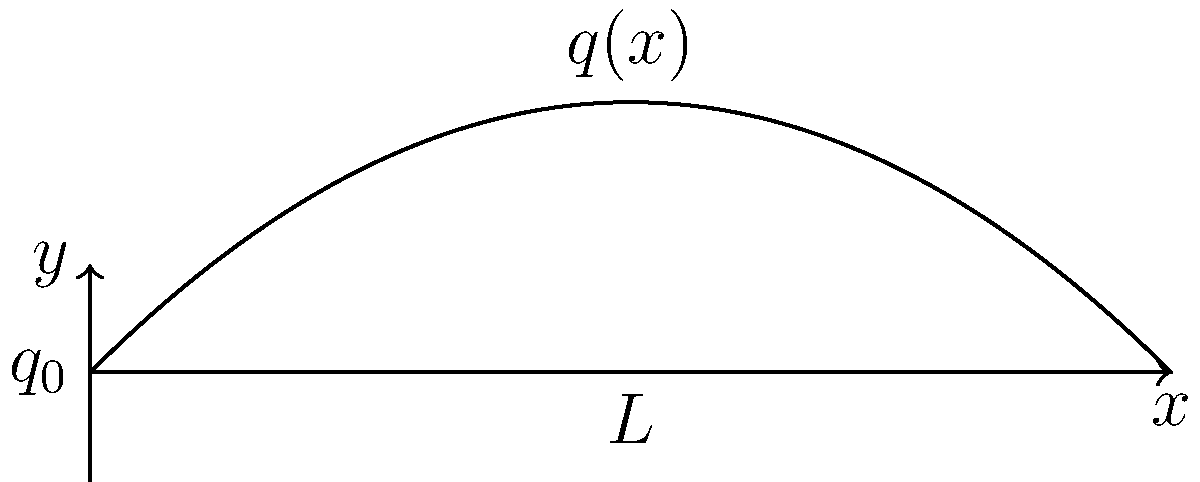In the context of Latin American revolutionary movements, consider a metaphorical "beam of resistance" represented by women's participation. This beam is subjected to a distributed load $q(x)$ that varies quadratically along its length $L$, as shown in the figure. The load represents the intensity of revolutionary activity, with $q(x) = q_0(1 - \frac{x^2}{L^2})$, where $q_0$ is the maximum intensity at $x = 0$. Determine the expression for the bending moment $M(x)$ at any point along the beam. To find the bending moment $M(x)$, we'll follow these steps:

1) The distributed load is given by:
   $$q(x) = q_0(1 - \frac{x^2}{L^2})$$

2) The shear force $V(x)$ is the integral of the negative of the distributed load:
   $$V(x) = -\int q(x) dx = -q_0 \int (1 - \frac{x^2}{L^2}) dx$$

3) Integrating:
   $$V(x) = -q_0 (x - \frac{x^3}{3L^2}) + C_1$$

4) The bending moment $M(x)$ is the integral of the shear force:
   $$M(x) = \int V(x) dx = -q_0 \int (x - \frac{x^3}{3L^2}) dx + C_1x + C_2$$

5) Integrating again:
   $$M(x) = -q_0 (\frac{x^2}{2} - \frac{x^4}{12L^2}) + C_1x + C_2$$

6) To determine the constants $C_1$ and $C_2$, we use the boundary conditions:
   At $x = 0$: $M(0) = 0$, which gives $C_2 = 0$
   At $x = L$: $M(L) = 0$, which gives:
   $$0 = -q_0 (\frac{L^2}{2} - \frac{L^4}{12L^2}) + C_1L$$
   $$C_1 = q_0 (\frac{L}{2} - \frac{L^3}{12L^2}) = \frac{5q_0L}{12}$$

7) Substituting back:
   $$M(x) = -q_0 (\frac{x^2}{2} - \frac{x^4}{12L^2}) + \frac{5q_0L}{12}x$$

8) Simplifying:
   $$M(x) = \frac{q_0L^2}{12}(5\frac{x}{L} - 6(\frac{x}{L})^2 + (\frac{x}{L})^4)$$

This expression represents the bending moment at any point $x$ along the beam.
Answer: $$M(x) = \frac{q_0L^2}{12}(5\frac{x}{L} - 6(\frac{x}{L})^2 + (\frac{x}{L})^4)$$ 